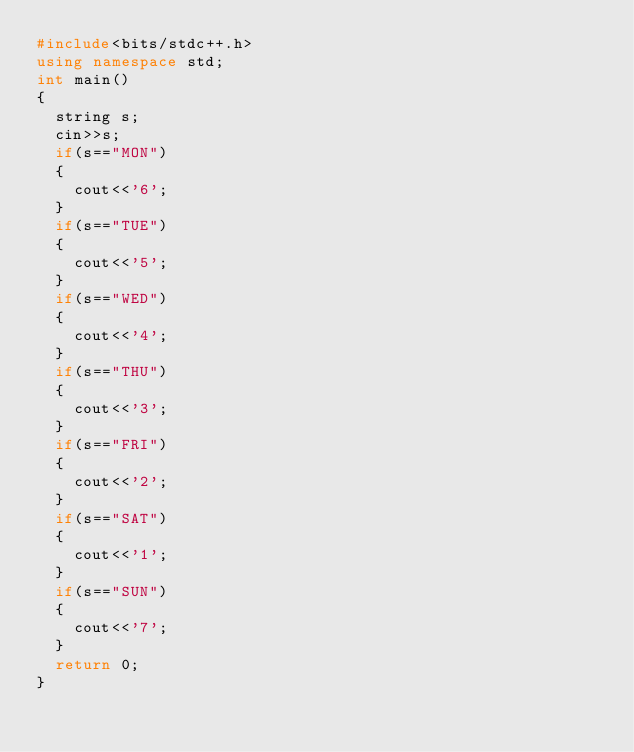<code> <loc_0><loc_0><loc_500><loc_500><_C++_>#include<bits/stdc++.h>
using namespace std;
int main()
{
	string s;
	cin>>s;
	if(s=="MON")
	{
		cout<<'6';
	}
	if(s=="TUE")
	{
		cout<<'5';
	}
	if(s=="WED")
	{
		cout<<'4';
	}
	if(s=="THU")
	{
		cout<<'3';
	}
	if(s=="FRI")
	{
		cout<<'2';
	}
	if(s=="SAT")
	{
		cout<<'1';
	}
	if(s=="SUN")
	{
		cout<<'7';
	}
	return 0;
}</code> 